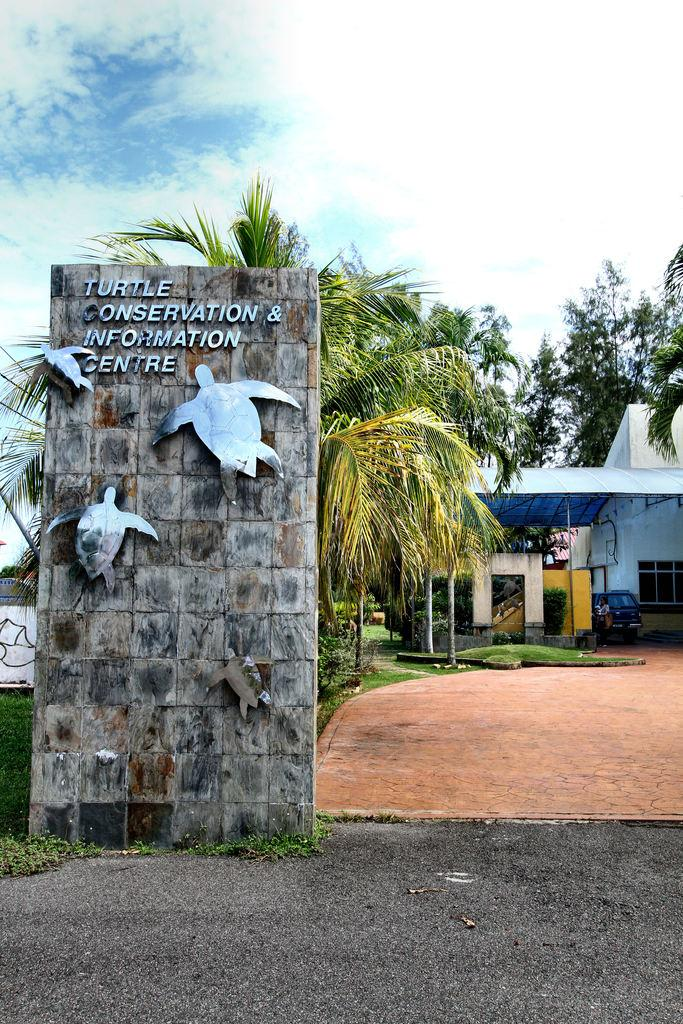What type of vegetation can be seen in the image? There are trees, plants, and grass visible in the image. What type of structures are present in the image? There are buildings in the image. What part of the natural environment is visible in the image? The sky is visible in the image, along with clouds. Can you tell me how many times the person in the image regrets their decision? There is no person present in the image, and therefore no decision-making or regret can be observed. What type of knee injury is visible in the image? There is no knee injury present in the image. 